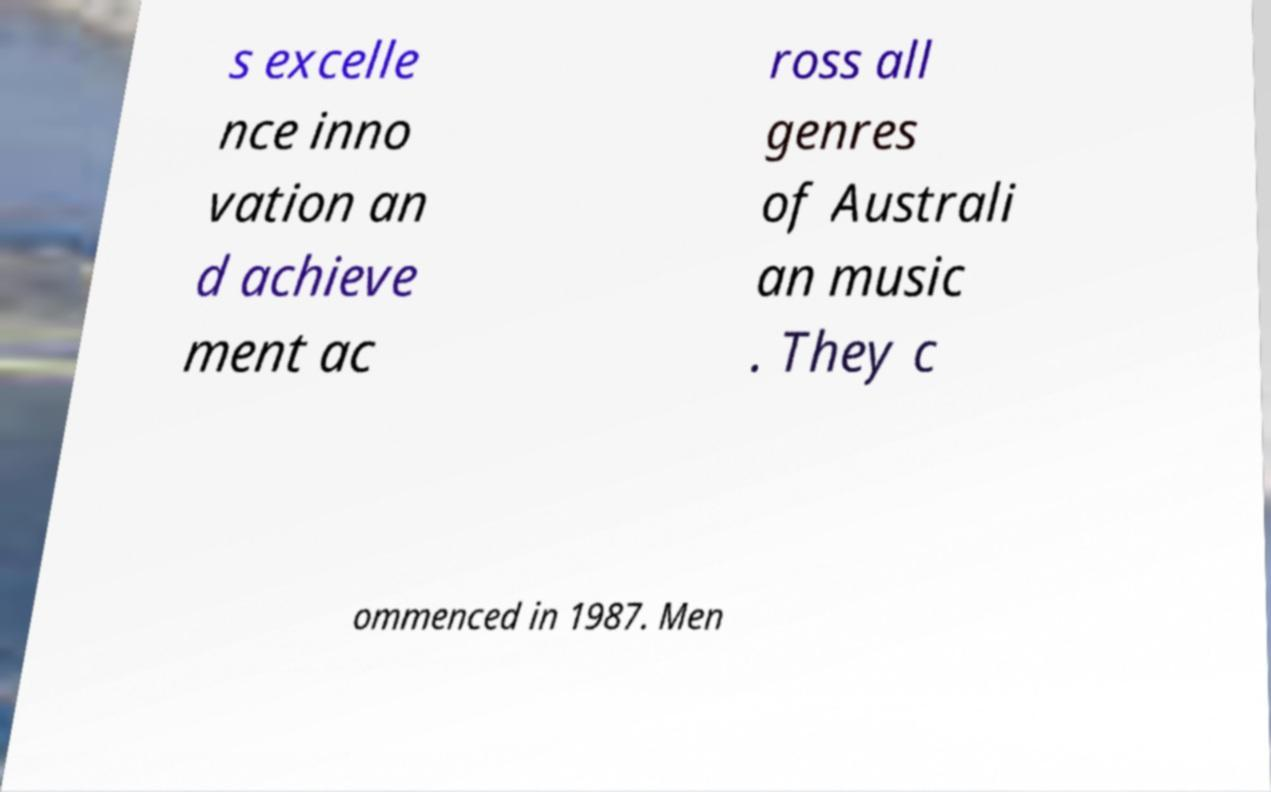Can you accurately transcribe the text from the provided image for me? s excelle nce inno vation an d achieve ment ac ross all genres of Australi an music . They c ommenced in 1987. Men 